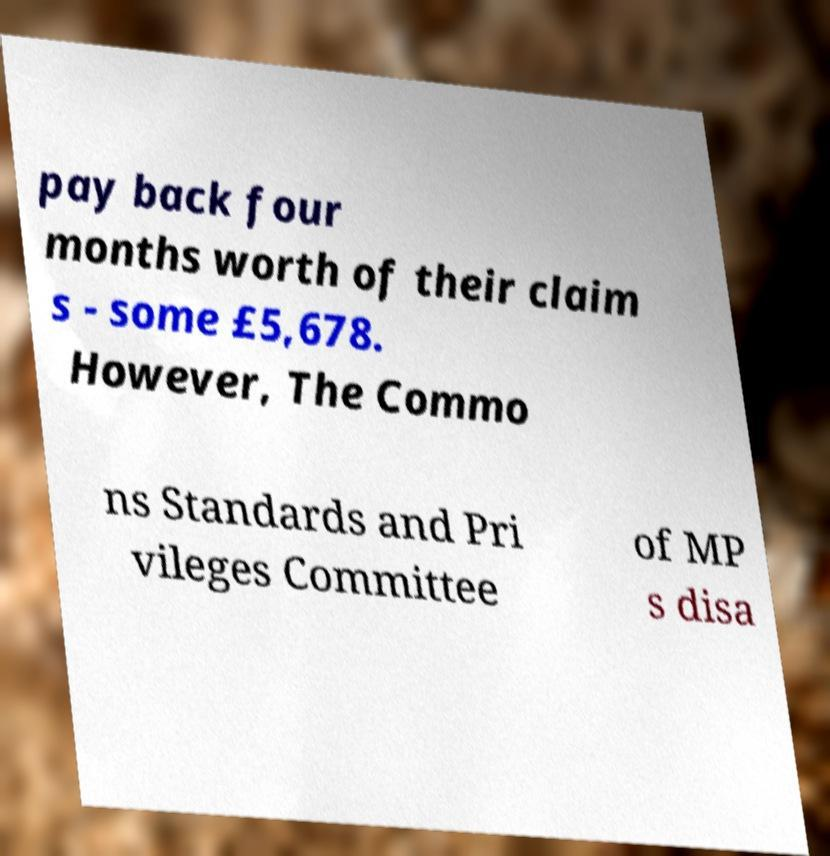For documentation purposes, I need the text within this image transcribed. Could you provide that? pay back four months worth of their claim s - some £5,678. However, The Commo ns Standards and Pri vileges Committee of MP s disa 